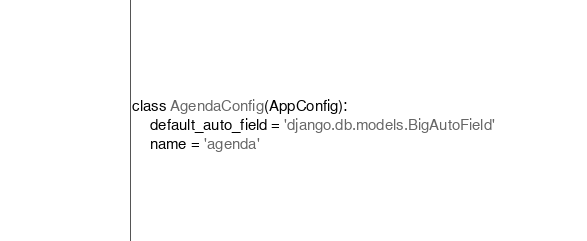<code> <loc_0><loc_0><loc_500><loc_500><_Python_>class AgendaConfig(AppConfig):
    default_auto_field = 'django.db.models.BigAutoField'
    name = 'agenda'
</code> 